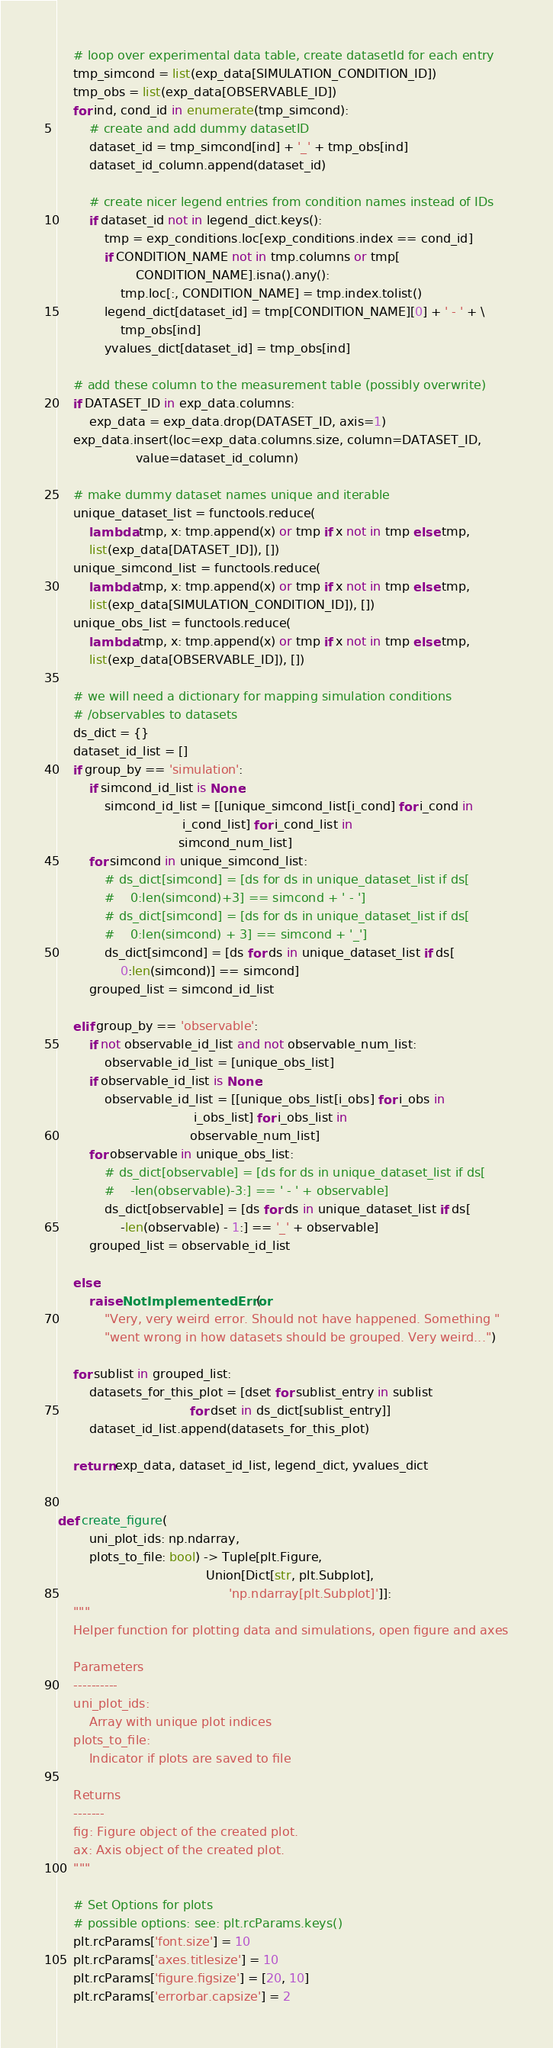<code> <loc_0><loc_0><loc_500><loc_500><_Python_>    # loop over experimental data table, create datasetId for each entry
    tmp_simcond = list(exp_data[SIMULATION_CONDITION_ID])
    tmp_obs = list(exp_data[OBSERVABLE_ID])
    for ind, cond_id in enumerate(tmp_simcond):
        # create and add dummy datasetID
        dataset_id = tmp_simcond[ind] + '_' + tmp_obs[ind]
        dataset_id_column.append(dataset_id)

        # create nicer legend entries from condition names instead of IDs
        if dataset_id not in legend_dict.keys():
            tmp = exp_conditions.loc[exp_conditions.index == cond_id]
            if CONDITION_NAME not in tmp.columns or tmp[
                    CONDITION_NAME].isna().any():
                tmp.loc[:, CONDITION_NAME] = tmp.index.tolist()
            legend_dict[dataset_id] = tmp[CONDITION_NAME][0] + ' - ' + \
                tmp_obs[ind]
            yvalues_dict[dataset_id] = tmp_obs[ind]

    # add these column to the measurement table (possibly overwrite)
    if DATASET_ID in exp_data.columns:
        exp_data = exp_data.drop(DATASET_ID, axis=1)
    exp_data.insert(loc=exp_data.columns.size, column=DATASET_ID,
                    value=dataset_id_column)

    # make dummy dataset names unique and iterable
    unique_dataset_list = functools.reduce(
        lambda tmp, x: tmp.append(x) or tmp if x not in tmp else tmp,
        list(exp_data[DATASET_ID]), [])
    unique_simcond_list = functools.reduce(
        lambda tmp, x: tmp.append(x) or tmp if x not in tmp else tmp,
        list(exp_data[SIMULATION_CONDITION_ID]), [])
    unique_obs_list = functools.reduce(
        lambda tmp, x: tmp.append(x) or tmp if x not in tmp else tmp,
        list(exp_data[OBSERVABLE_ID]), [])

    # we will need a dictionary for mapping simulation conditions
    # /observables to datasets
    ds_dict = {}
    dataset_id_list = []
    if group_by == 'simulation':
        if simcond_id_list is None:
            simcond_id_list = [[unique_simcond_list[i_cond] for i_cond in
                                i_cond_list] for i_cond_list in
                               simcond_num_list]
        for simcond in unique_simcond_list:
            # ds_dict[simcond] = [ds for ds in unique_dataset_list if ds[
            #    0:len(simcond)+3] == simcond + ' - ']
            # ds_dict[simcond] = [ds for ds in unique_dataset_list if ds[
            #    0:len(simcond) + 3] == simcond + '_']
            ds_dict[simcond] = [ds for ds in unique_dataset_list if ds[
                0:len(simcond)] == simcond]
        grouped_list = simcond_id_list

    elif group_by == 'observable':
        if not observable_id_list and not observable_num_list:
            observable_id_list = [unique_obs_list]
        if observable_id_list is None:
            observable_id_list = [[unique_obs_list[i_obs] for i_obs in
                                   i_obs_list] for i_obs_list in
                                  observable_num_list]
        for observable in unique_obs_list:
            # ds_dict[observable] = [ds for ds in unique_dataset_list if ds[
            #    -len(observable)-3:] == ' - ' + observable]
            ds_dict[observable] = [ds for ds in unique_dataset_list if ds[
                -len(observable) - 1:] == '_' + observable]
        grouped_list = observable_id_list

    else:
        raise NotImplementedError(
            "Very, very weird error. Should not have happened. Something "
            "went wrong in how datasets should be grouped. Very weird...")

    for sublist in grouped_list:
        datasets_for_this_plot = [dset for sublist_entry in sublist
                                  for dset in ds_dict[sublist_entry]]
        dataset_id_list.append(datasets_for_this_plot)

    return exp_data, dataset_id_list, legend_dict, yvalues_dict


def create_figure(
        uni_plot_ids: np.ndarray,
        plots_to_file: bool) -> Tuple[plt.Figure,
                                      Union[Dict[str, plt.Subplot],
                                            'np.ndarray[plt.Subplot]']]:
    """
    Helper function for plotting data and simulations, open figure and axes

    Parameters
    ----------
    uni_plot_ids:
        Array with unique plot indices
    plots_to_file:
        Indicator if plots are saved to file

    Returns
    -------
    fig: Figure object of the created plot.
    ax: Axis object of the created plot.
    """

    # Set Options for plots
    # possible options: see: plt.rcParams.keys()
    plt.rcParams['font.size'] = 10
    plt.rcParams['axes.titlesize'] = 10
    plt.rcParams['figure.figsize'] = [20, 10]
    plt.rcParams['errorbar.capsize'] = 2
</code> 